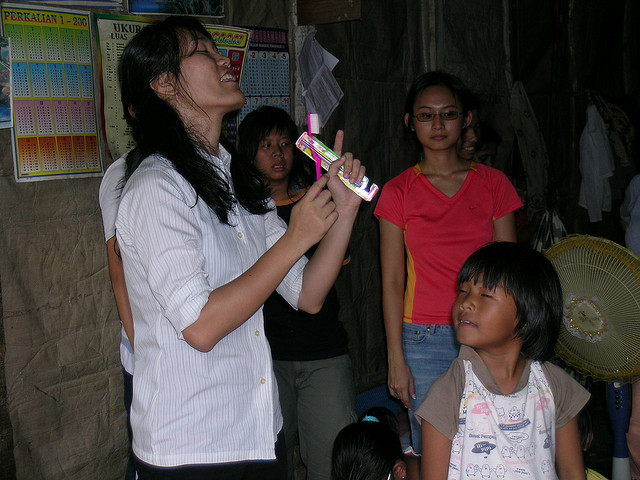<image>Is this picture in the United States? I am not sure if the picture is in the United States. Is this picture in the United States? I am not sure if this picture is in the United States. It can be in a different country. 